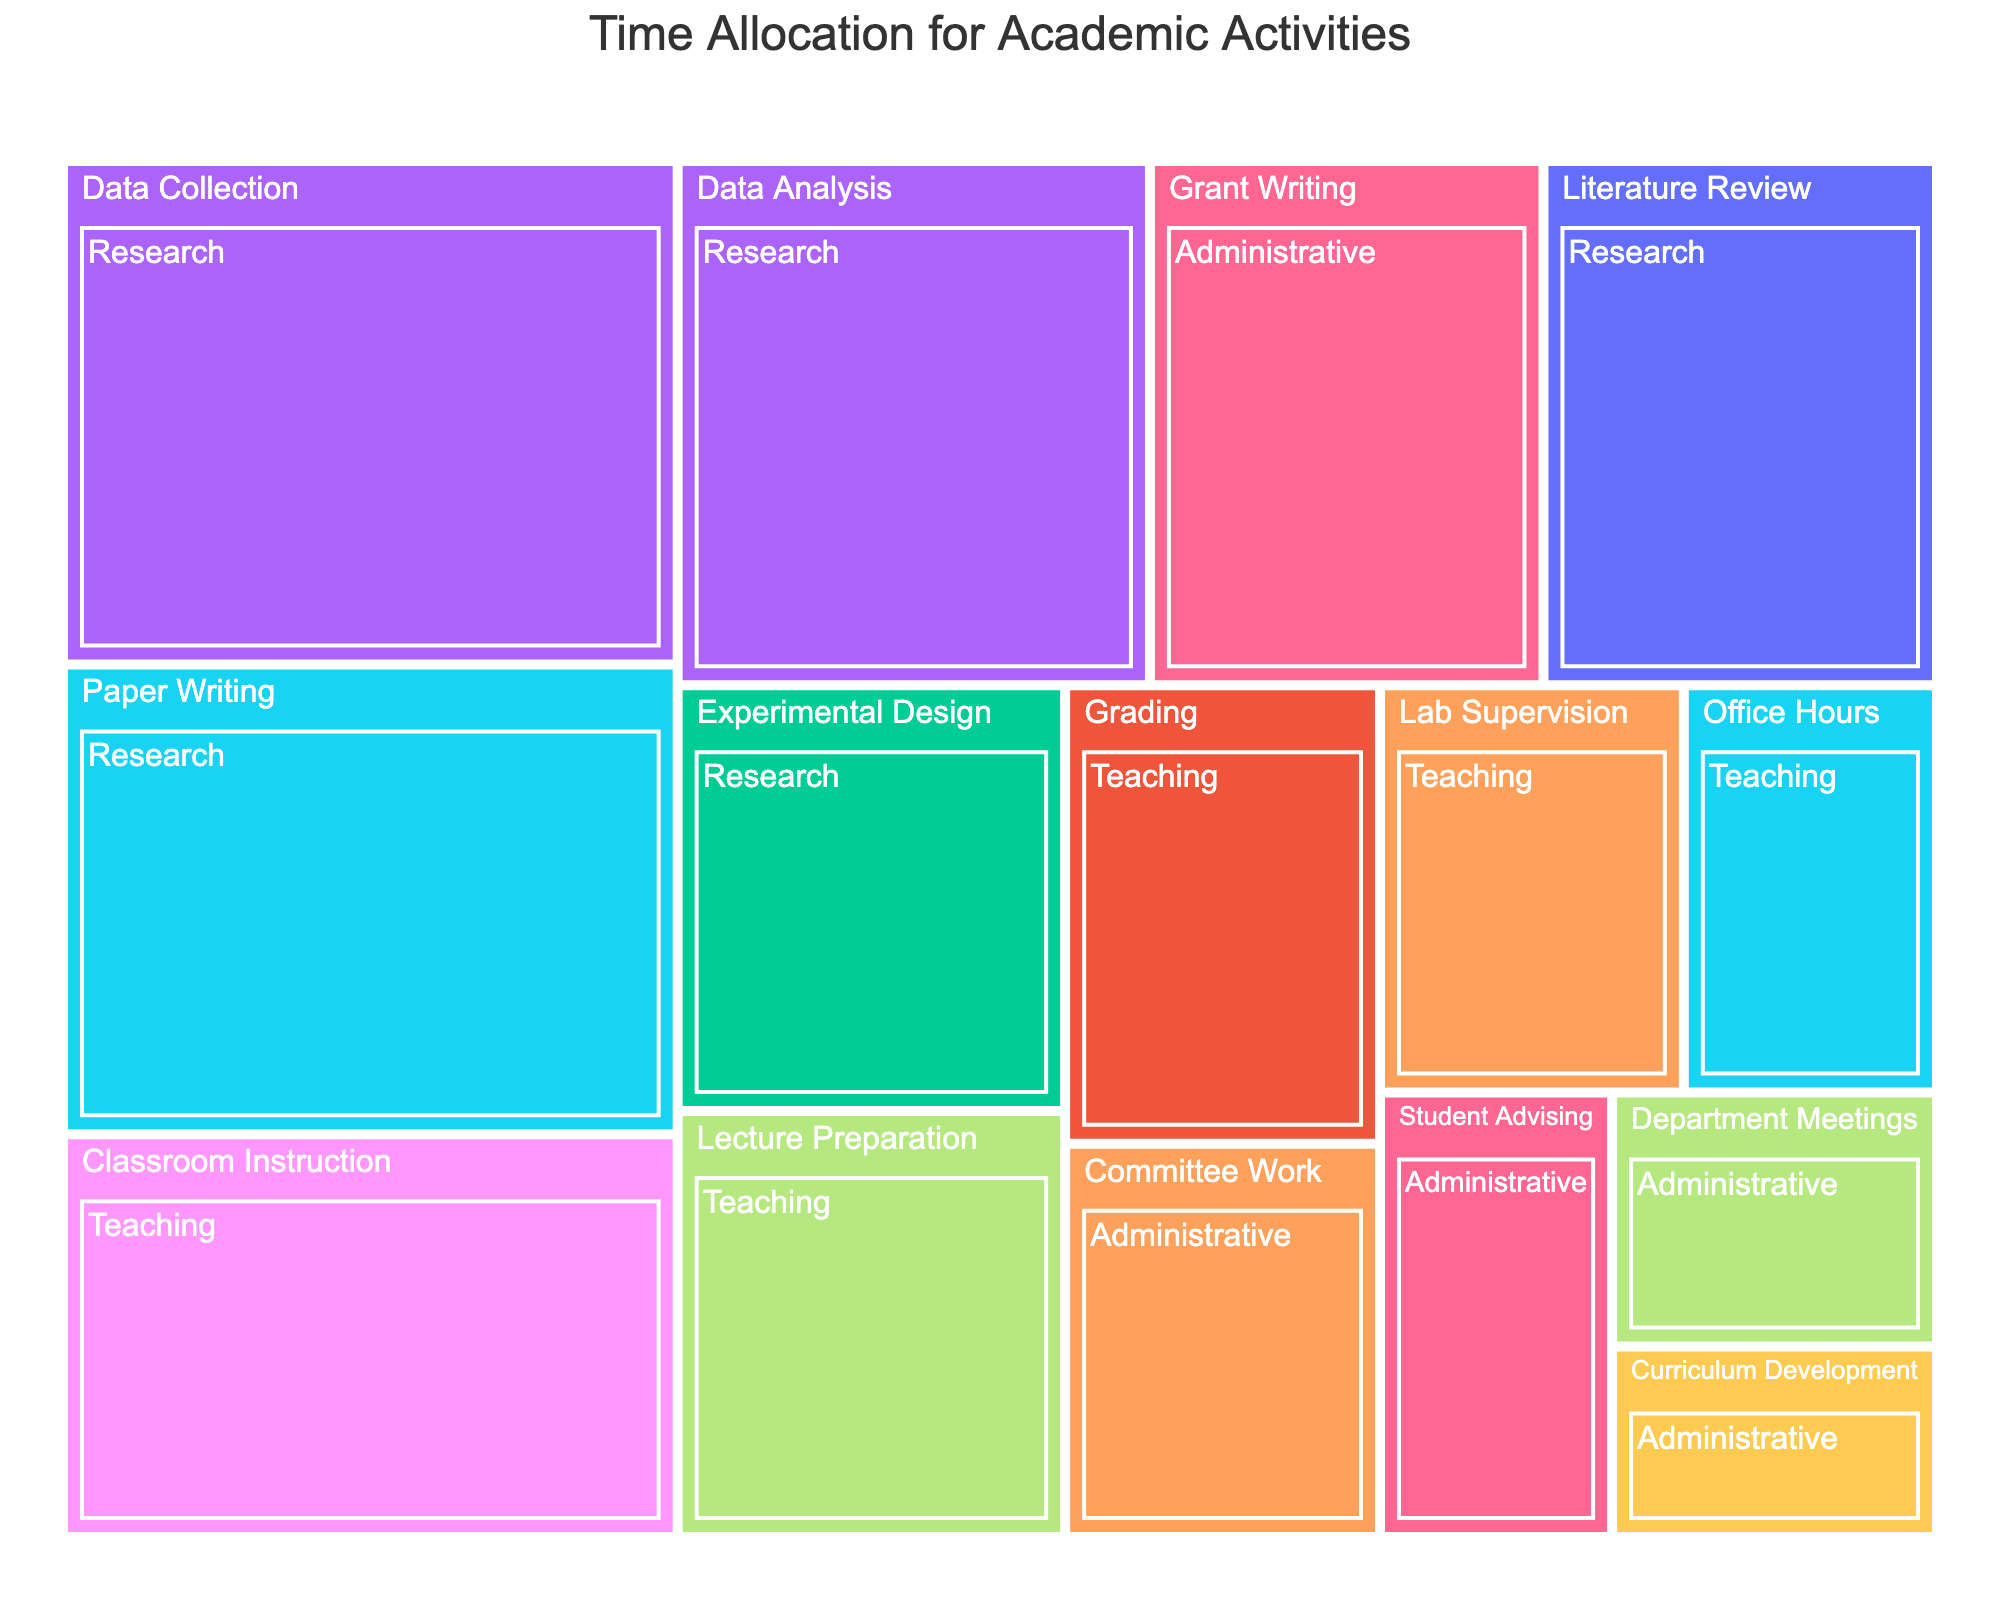What's the title of the Treemap? The title is located at the top of the figure, centered, and can be easily read to identify the main focus of the plot.
Answer: Time Allocation for Academic Activities How many hours are allocated to 'Paper Writing' in the 'Research' category? Locate the 'Research' category, find the 'Paper Writing' activity within it, and read the hours value associated with it.
Answer: 14 Which activity has the highest time allocation in the 'Teaching' category? Within the 'Teaching' category, compare the hours allocated to each activity to determine which has the maximum value.
Answer: Classroom Instruction What is the total time allocated for 'Administrative' tasks? Sum the hours of all activities under the 'Administrative' category: Department Meetings (4), Grant Writing (10), Committee Work (6), Student Advising (5), Curriculum Development (3). The total is 4 + 10 + 6 + 5 + 3.
Answer: 28 How do the hours for 'Data Collection' compare with 'Lecture Preparation'? Find the hours for 'Data Collection' under 'Research' and 'Lecture Preparation' under 'Teaching'. Compare the two values.
Answer: Data Collection has more hours (15 vs 8) What's the combined time allocation for 'Literature Review' and 'Data Analysis' in the 'Research' category? Add the hours allocated for 'Literature Review' (10) and 'Data Analysis' (12) under 'Research'. The combined hours are 10 + 12.
Answer: 22 Which 'Administrative' activity has the least time allocation? Identify the activity under 'Administrative' that has the smallest hours value by comparing all activities.
Answer: Curriculum Development What percentage of total 'Research' hours is spent on 'Experimental Design'? Sum the total hours for all ‘Research’ activities, and then find the percentage of that total allocated to 'Experimental Design'. Total Research hours are 10 + 8 + 15 + 12 + 14 = 59. Experimental Design hours are 8. The percentage is (8/59) * 100.
Answer: 13.56% How does the combined time for 'Teaching' and 'Administrative' compare with 'Research'? Sum the hours of all activities under 'Teaching' and 'Administrative' categories, and then compare the total with 'Research'. Teaching: 8+12+6+7+5=38, Administrative: 4+10+6+5+3=28. Combined Teaching and Administrative: 38+28=66. Research: 59. Compare the two totals.
Answer: Combined hours for Teaching and Administrative are greater by 7 Which category has the most time allocation overall? Sum the hours for each category and determine which has the highest total. Research: 59, Teaching: 38, Administrative: 28. The category with the highest sum is the one with the most time allocation.
Answer: Research 